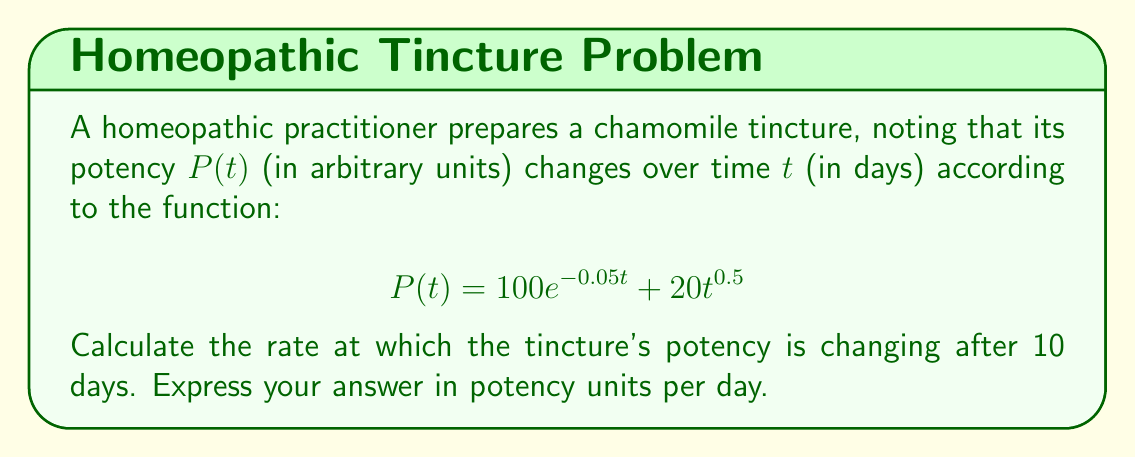Could you help me with this problem? To solve this problem, we need to find the derivative of the potency function $P(t)$ and evaluate it at $t = 10$ days. This will give us the instantaneous rate of change of the tincture's potency after 10 days.

1) First, let's find the derivative of $P(t)$ using the sum rule and chain rule:

   $$\frac{d}{dt}P(t) = \frac{d}{dt}(100e^{-0.05t}) + \frac{d}{dt}(20t^{0.5})$$

2) For the first term:
   $$\frac{d}{dt}(100e^{-0.05t}) = 100 \cdot (-0.05) \cdot e^{-0.05t} = -5e^{-0.05t}$$

3) For the second term:
   $$\frac{d}{dt}(20t^{0.5}) = 20 \cdot 0.5 \cdot t^{-0.5} = \frac{10}{\sqrt{t}}$$

4) Combining these results:
   $$P'(t) = -5e^{-0.05t} + \frac{10}{\sqrt{t}}$$

5) Now, we evaluate this at $t = 10$:
   $$P'(10) = -5e^{-0.05(10)} + \frac{10}{\sqrt{10}}$$

6) Simplifying:
   $$P'(10) = -5e^{-0.5} + \frac{10}{\sqrt{10}} \approx -3.033 + 3.162 \approx 0.129$$

Therefore, after 10 days, the potency of the tincture is increasing at a rate of approximately 0.129 potency units per day.
Answer: $0.129$ potency units per day 